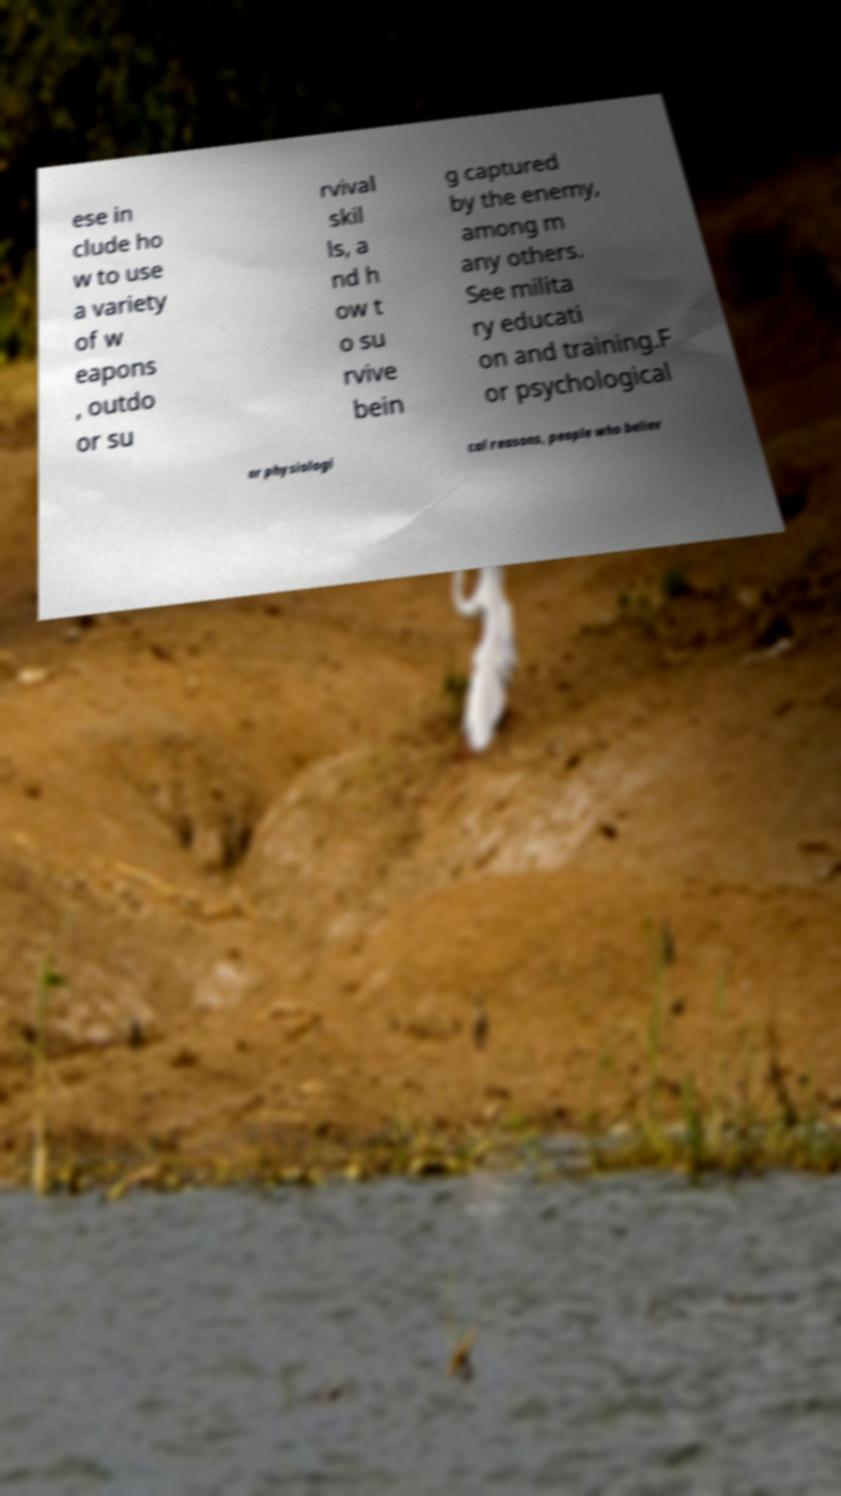Can you accurately transcribe the text from the provided image for me? ese in clude ho w to use a variety of w eapons , outdo or su rvival skil ls, a nd h ow t o su rvive bein g captured by the enemy, among m any others. See milita ry educati on and training.F or psychological or physiologi cal reasons, people who believ 